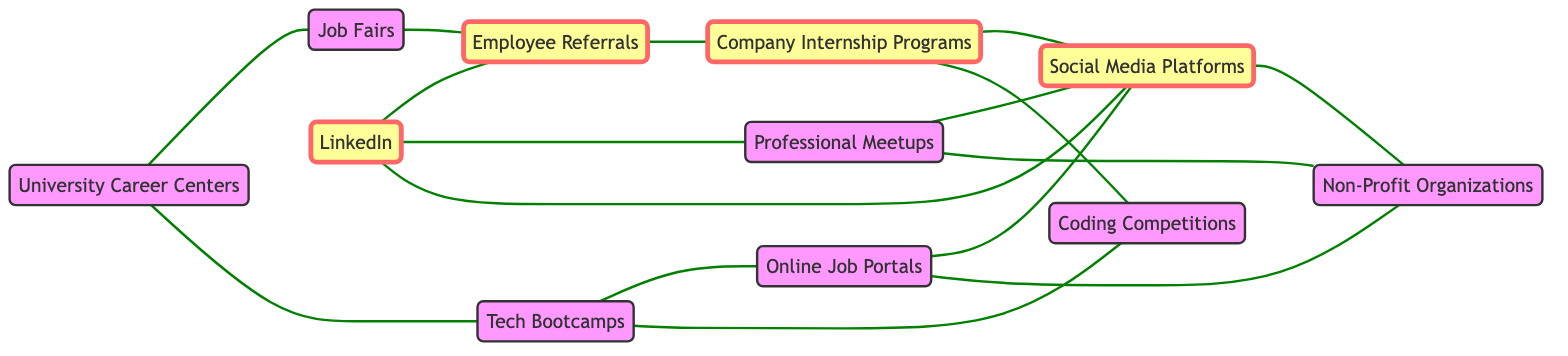What are the total number of nodes in this diagram? To find the total nodes, count each unique referral source represented in the diagram. Given the data, there are 11 unique nodes listed under the "nodes" section.
Answer: 11 Which two nodes are directly connected by an edge aside from Employee Referrals? Looking at the edges, many nodes connect with each other; specifically, University Career Centers connects directly to Job Fairs and Tech Bootcamps, and Job Fairs also connects directly to Employee Referrals. However, excluding Employee Referrals, a direct connection exists between University Career Centers and Job Fairs.
Answer: University Career Centers and Job Fairs How many connections or edges does Tech Bootcamps have? To find the number of connections (edges) for Tech Bootcamps, review the edges in the data that connect with the Tech Bootcamps node. Tech Bootcamps has two connections: one to Online Job Portals and one to Coding Competitions.
Answer: 2 Which nodes are connected to Social Media Platforms? Here, we identify nodes that share edges with Social Media Platforms by reviewing its connection details. Social Media Platforms is connected to LinkedIn, Online Job Portals, Company Internship Programs, and Non-Profit Organizations.
Answer: LinkedIn, Online Job Portals, Company Internship Programs, Non-Profit Organizations What is the relationship between Company Internship Programs and other nodes? Analyzing Company Internship Programs in relation to other nodes involves checking the edges rooted in this node. Company Internship Programs connects directly to Social Media Platforms and Coding Competitions, identifying it as a point of interaction.
Answer: Social Media Platforms and Coding Competitions 